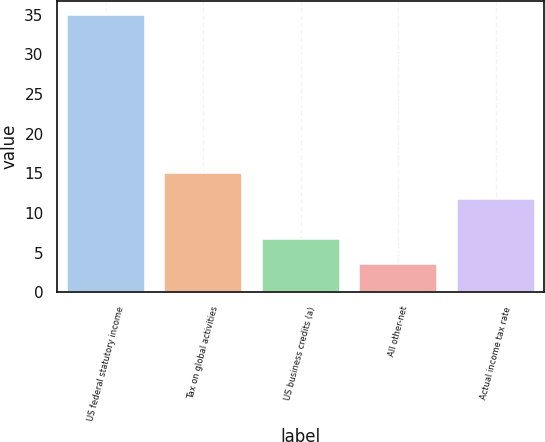Convert chart. <chart><loc_0><loc_0><loc_500><loc_500><bar_chart><fcel>US federal statutory income<fcel>Tax on global activities<fcel>US business credits (a)<fcel>All other-net<fcel>Actual income tax rate<nl><fcel>35<fcel>15<fcel>6.65<fcel>3.5<fcel>11.8<nl></chart> 